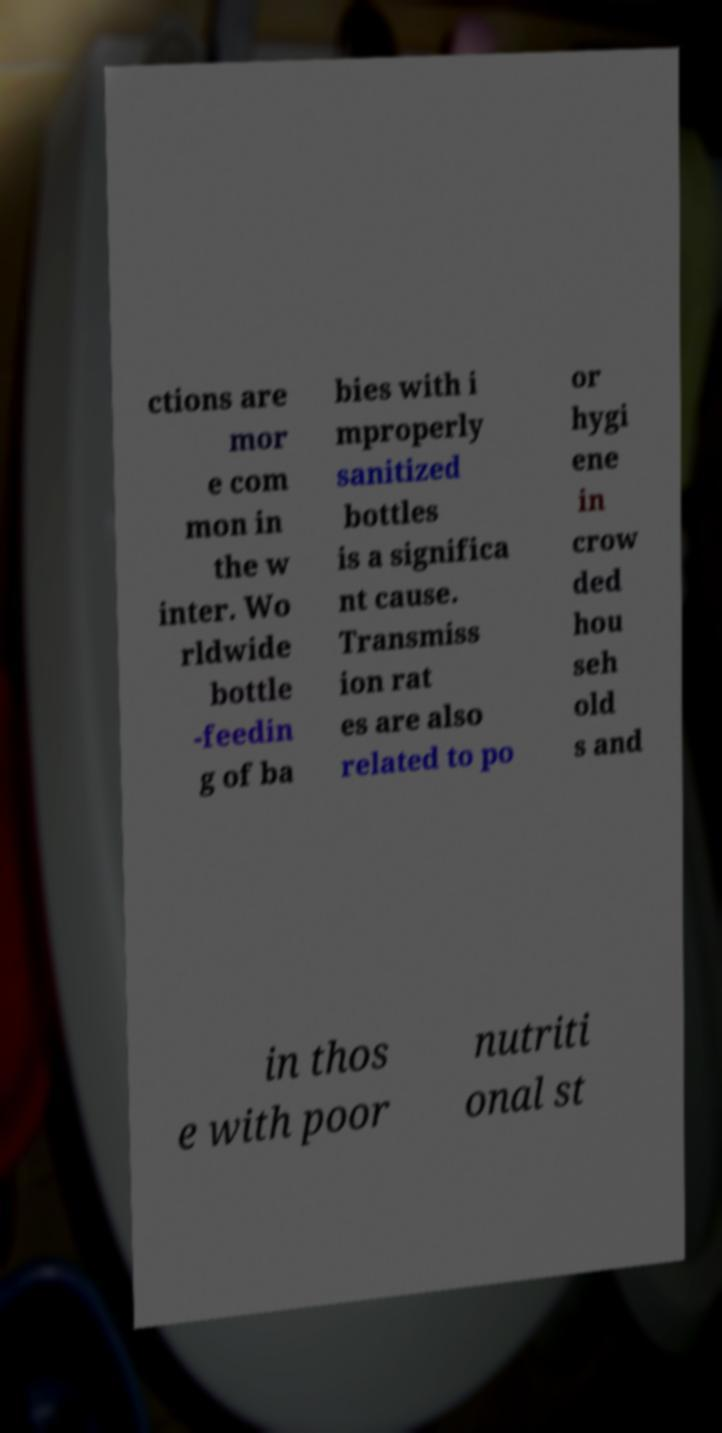I need the written content from this picture converted into text. Can you do that? ctions are mor e com mon in the w inter. Wo rldwide bottle -feedin g of ba bies with i mproperly sanitized bottles is a significa nt cause. Transmiss ion rat es are also related to po or hygi ene in crow ded hou seh old s and in thos e with poor nutriti onal st 